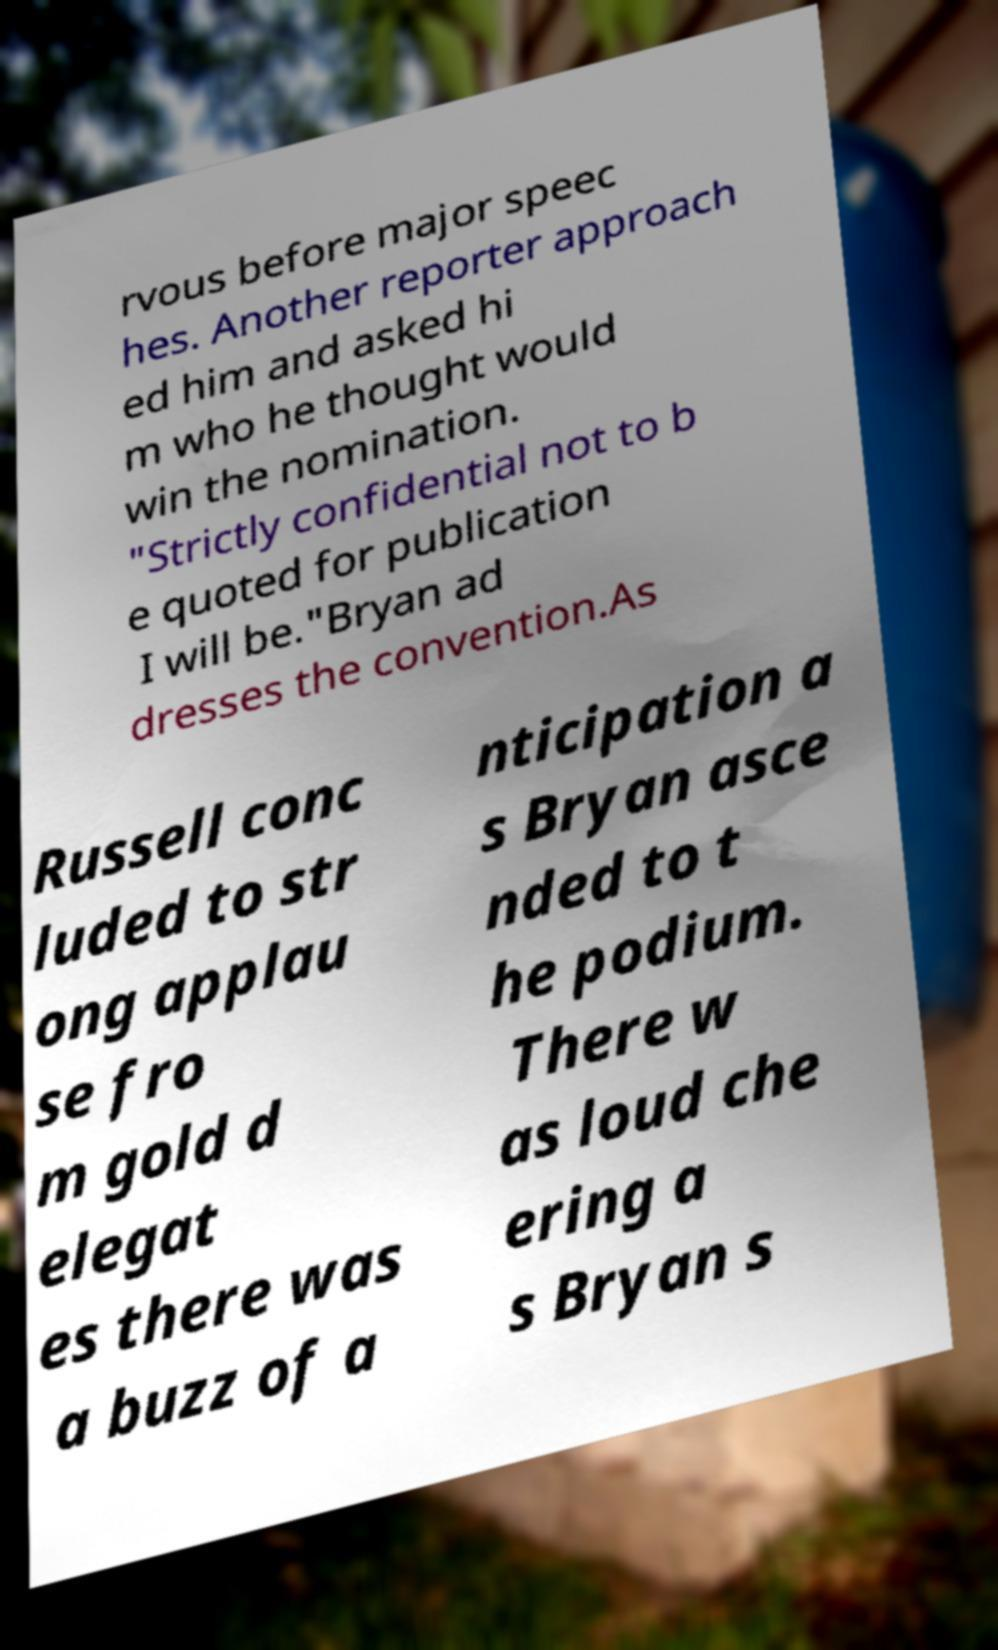For documentation purposes, I need the text within this image transcribed. Could you provide that? rvous before major speec hes. Another reporter approach ed him and asked hi m who he thought would win the nomination. "Strictly confidential not to b e quoted for publication I will be."Bryan ad dresses the convention.As Russell conc luded to str ong applau se fro m gold d elegat es there was a buzz of a nticipation a s Bryan asce nded to t he podium. There w as loud che ering a s Bryan s 